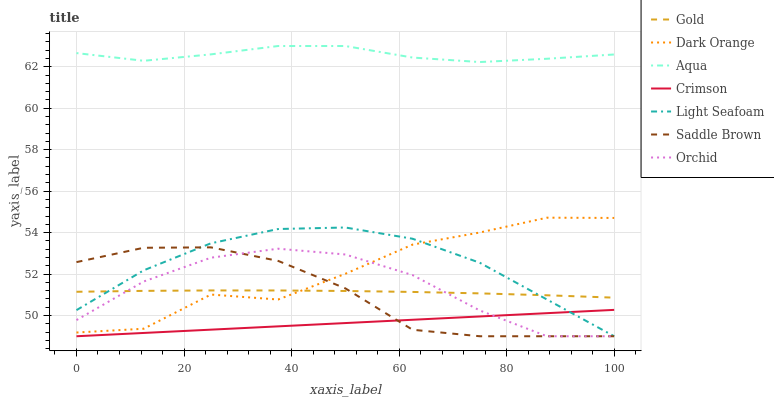Does Crimson have the minimum area under the curve?
Answer yes or no. Yes. Does Aqua have the maximum area under the curve?
Answer yes or no. Yes. Does Gold have the minimum area under the curve?
Answer yes or no. No. Does Gold have the maximum area under the curve?
Answer yes or no. No. Is Crimson the smoothest?
Answer yes or no. Yes. Is Dark Orange the roughest?
Answer yes or no. Yes. Is Gold the smoothest?
Answer yes or no. No. Is Gold the roughest?
Answer yes or no. No. Does Gold have the lowest value?
Answer yes or no. No. Does Aqua have the highest value?
Answer yes or no. Yes. Does Gold have the highest value?
Answer yes or no. No. Is Crimson less than Gold?
Answer yes or no. Yes. Is Aqua greater than Crimson?
Answer yes or no. Yes. Does Saddle Brown intersect Light Seafoam?
Answer yes or no. Yes. Is Saddle Brown less than Light Seafoam?
Answer yes or no. No. Is Saddle Brown greater than Light Seafoam?
Answer yes or no. No. Does Crimson intersect Gold?
Answer yes or no. No. 